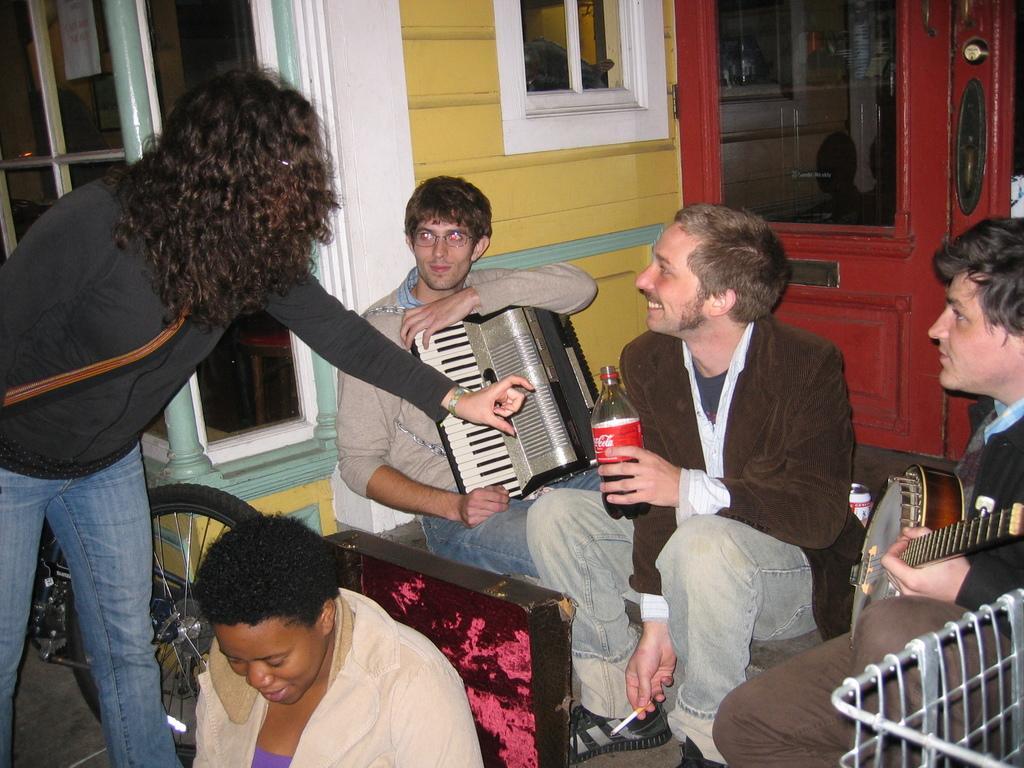How would you summarize this image in a sentence or two? In this picture we can see a group of people are sitting and a person is standing and the two people are holding some music instruments and a person is holding a bottle. Behind the people there is a wall with windows. 